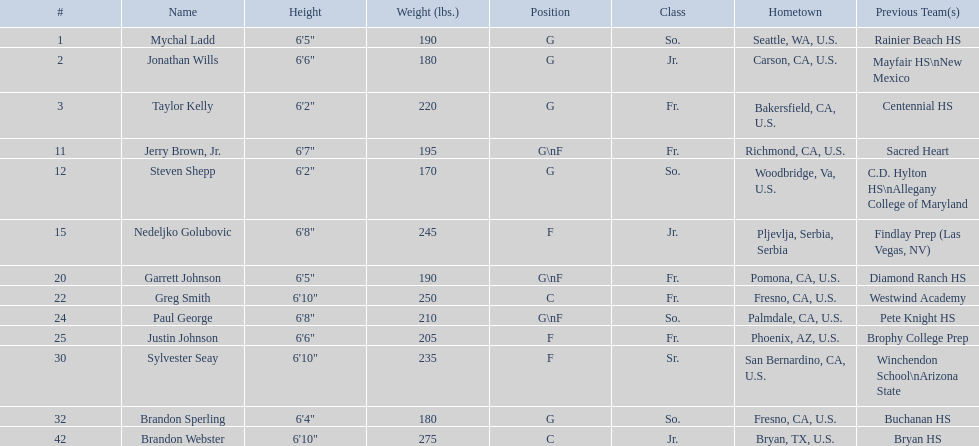Which players are forwards? Nedeljko Golubovic, Paul George, Justin Johnson, Sylvester Seay. What are the heights of these players? Nedeljko Golubovic, 6'8", Paul George, 6'8", Justin Johnson, 6'6", Sylvester Seay, 6'10". Of these players, who is the shortest? Justin Johnson. Can you provide the names of all players? Mychal Ladd, Jonathan Wills, Taylor Kelly, Jerry Brown, Jr., Steven Shepp, Nedeljko Golubovic, Garrett Johnson, Greg Smith, Paul George, Justin Johnson, Sylvester Seay, Brandon Sperling, Brandon Webster. Which players have a height exceeding 6'8? Nedeljko Golubovic, Greg Smith, Paul George, Sylvester Seay, Brandon Webster. How tall does paul george stand? 6'8". How tall is greg smith? 6'10". Among these two, who has the greater height? Greg Smith. 